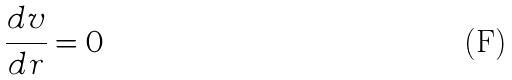<formula> <loc_0><loc_0><loc_500><loc_500>\frac { d v } { d r } = 0</formula> 